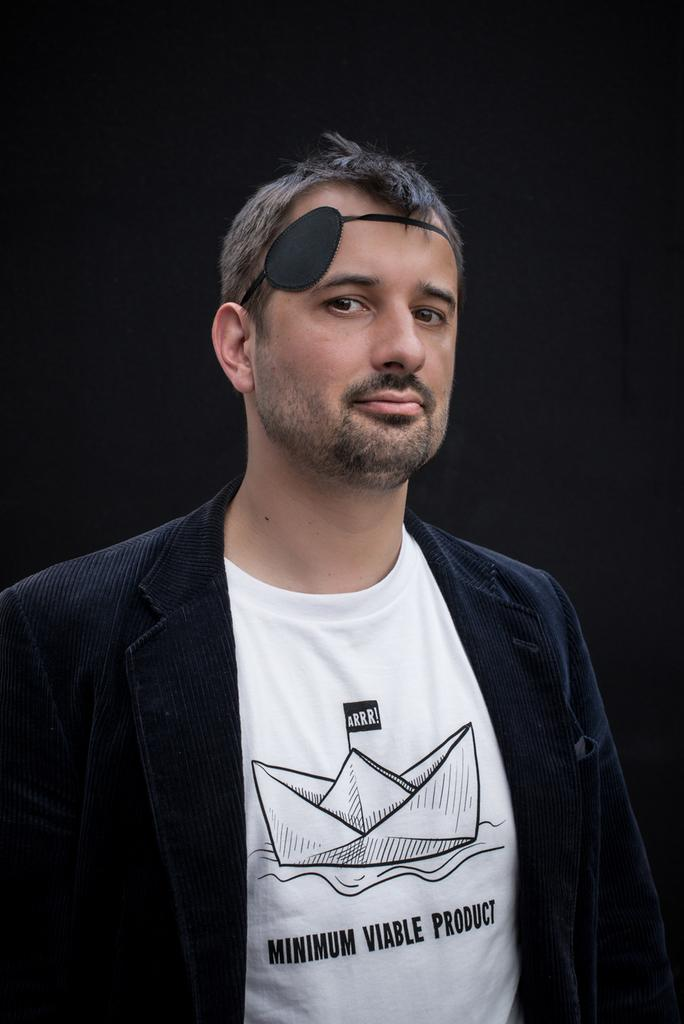What is present in the image? There is a person in the image. What is the person wearing? The person is wearing a white t-shirt. What is the person's posture in the image? The person is standing. What can be seen behind the person in the image? There is a black background in the image. What is depicted on the person's t-shirt? There is a picture of a boat on the t-shirt. Are there any words on the t-shirt? Yes, there is text on the t-shirt. How many secretaries are visible in the image? There are no secretaries present in the image; it features a person wearing a t-shirt with a picture of a boat and text. Are there any men in the image? The provided facts do not specify the gender of the person in the image, so it cannot be definitively determined if the person is a man or not. 